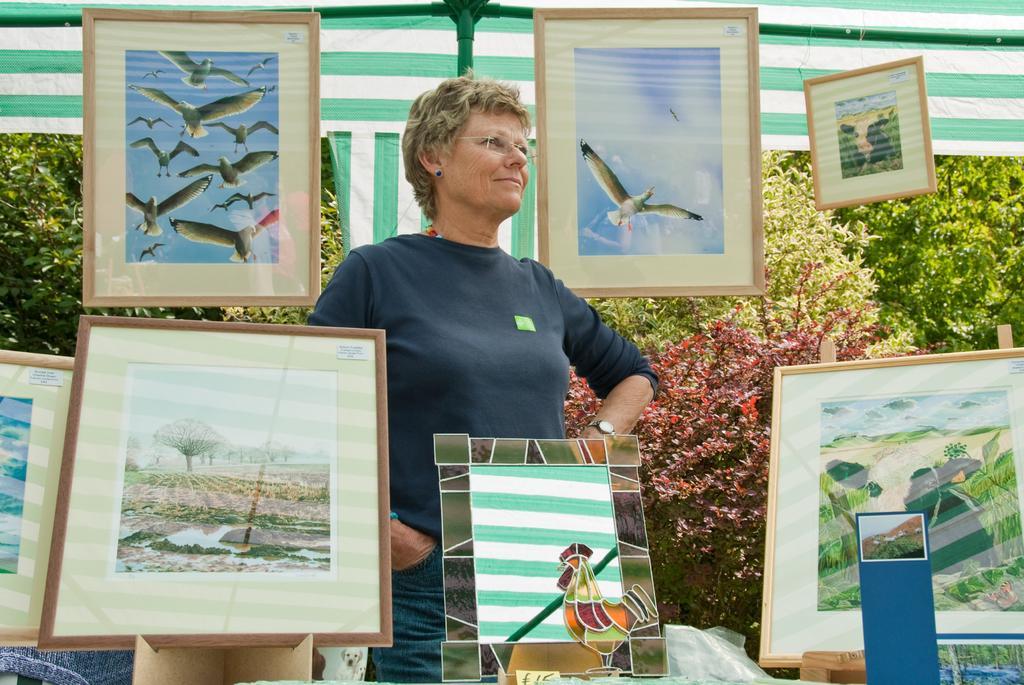Describe this image in one or two sentences. In this image in the center there is one woman who is standing and also there are a group of photo frames, in the background there are some plants and at the top there is tent and poles. 